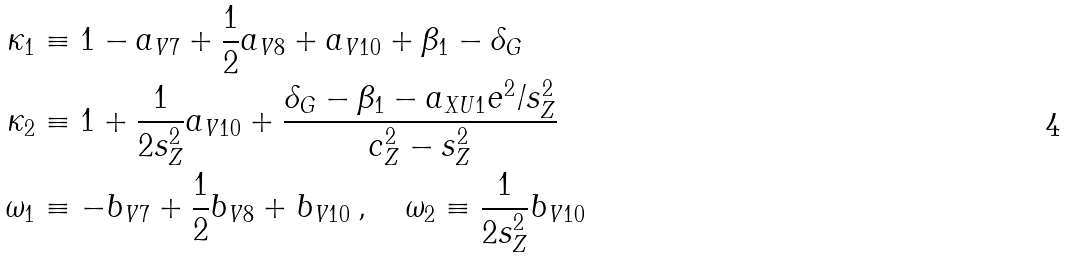Convert formula to latex. <formula><loc_0><loc_0><loc_500><loc_500>\kappa _ { 1 } & \equiv 1 - a _ { V 7 } + \frac { 1 } { 2 } a _ { V 8 } + a _ { V 1 0 } + \beta _ { 1 } - \delta _ { G } \\ \kappa _ { 2 } & \equiv 1 + \frac { 1 } { 2 s ^ { 2 } _ { Z } } a _ { V 1 0 } + \frac { \delta _ { G } - \beta _ { 1 } - a _ { X U 1 } e ^ { 2 } / s ^ { 2 } _ { Z } } { c ^ { 2 } _ { Z } - s ^ { 2 } _ { Z } } \\ \omega _ { 1 } & \equiv - b _ { V 7 } + \frac { 1 } { 2 } b _ { V 8 } + b _ { V 1 0 } \, , \quad \omega _ { 2 } \equiv \frac { 1 } { 2 s ^ { 2 } _ { Z } } b _ { V 1 0 }</formula> 